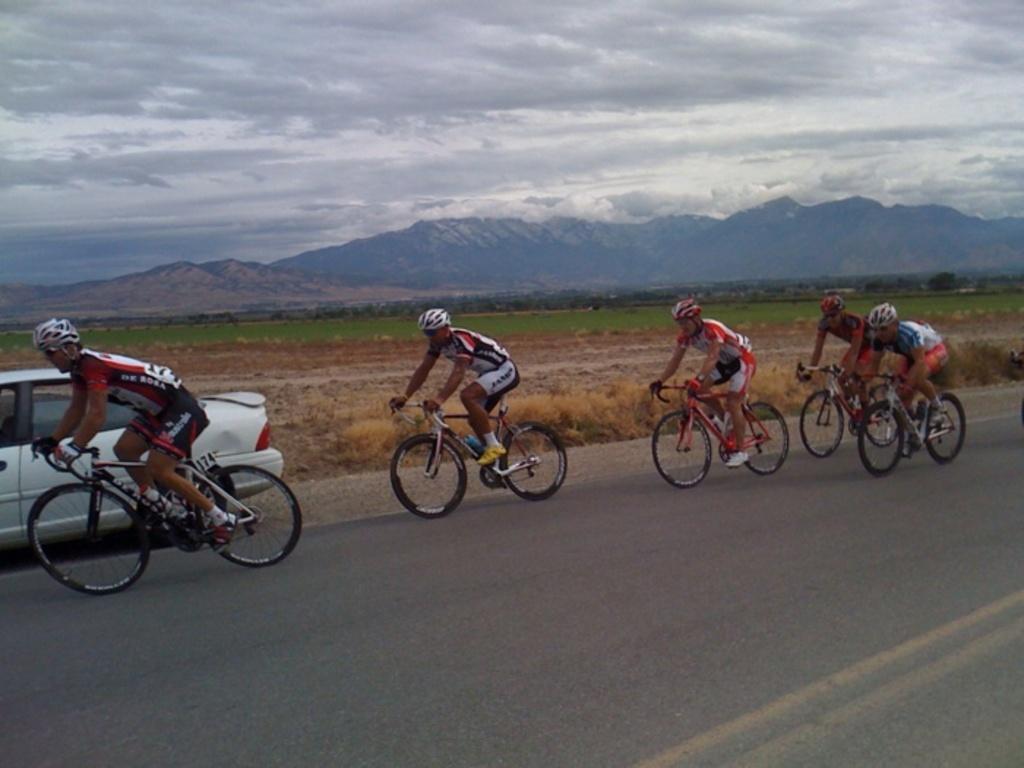In one or two sentences, can you explain what this image depicts? In this picture we can see a car and five men wore helmets, shoes and riding bicycles on the road, grass, mountains and in the background we can see the sky with clouds. 